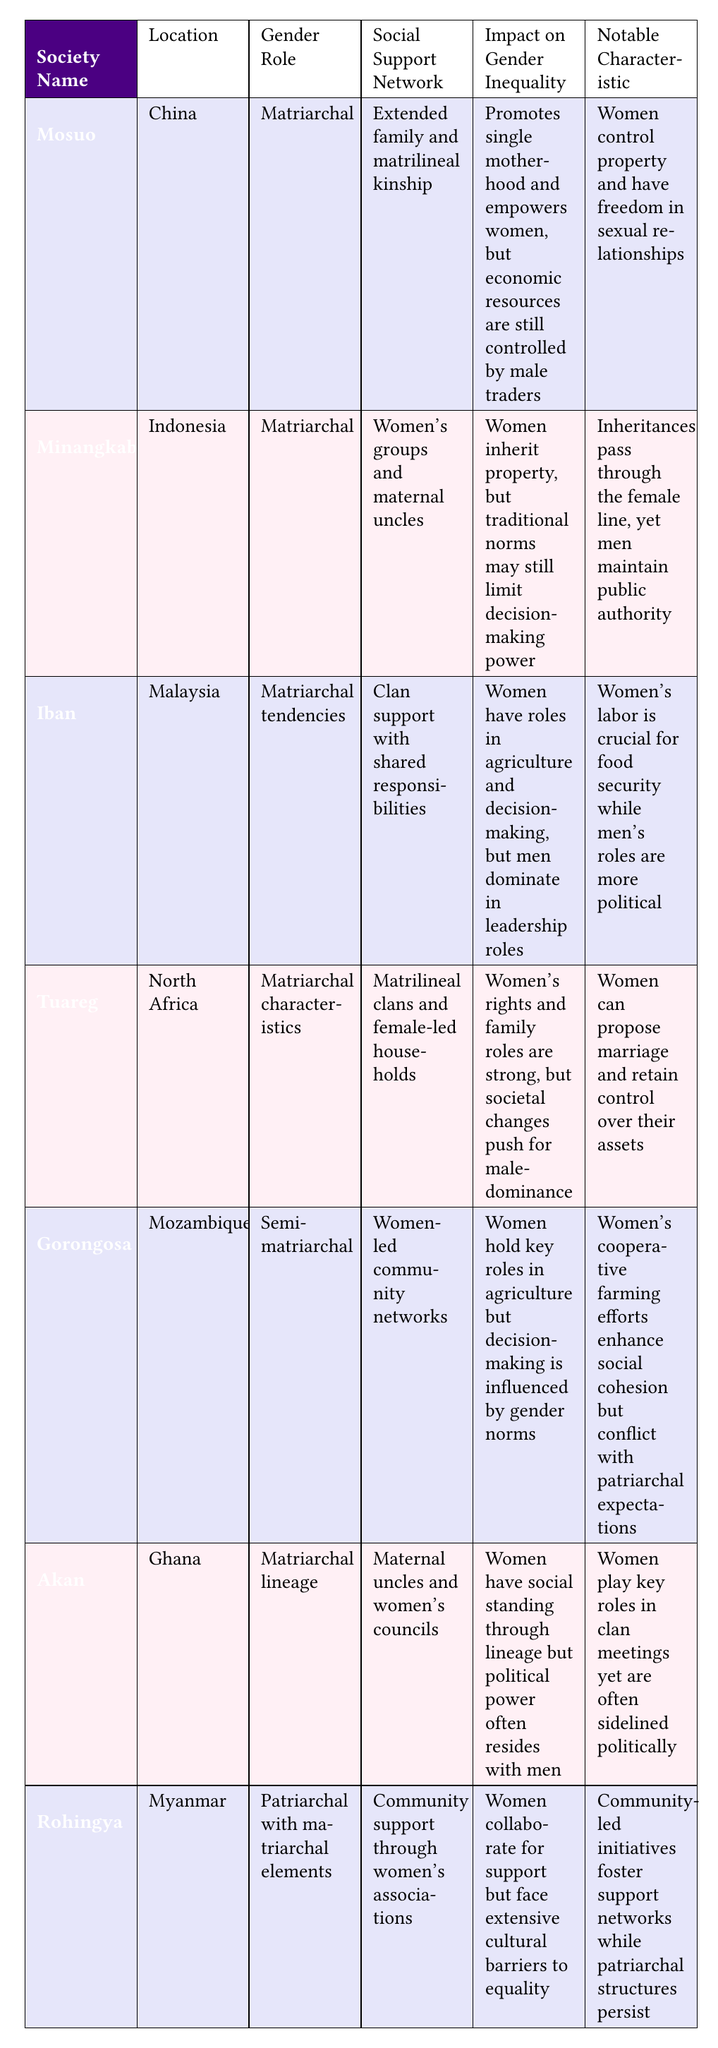What matriarchal society allows women to propose marriage? The table indicates that in the Tuareg society of North Africa, women have the ability to propose marriage. This can be directly referenced from the notable characteristic column of their row in the table.
Answer: Tuareg Which society has women's groups and maternal uncles as their social support network? According to the table, the Minangkabau society in Indonesia utilizes women's groups and maternal uncles as their social support network. This information is directly stated in the corresponding column for that society.
Answer: Minangkabau Are women in the Iban society granted leadership roles? The table reveals that while women in the Iban society have critical roles in agriculture and decision-making, men dominate leadership roles. Thus, the answer is no, women are not granted leadership roles.
Answer: No What is the notable characteristic for the Akan society? The table specifies that the notable characteristic of the Akan society in Ghana is that women play key roles in clan meetings but are often sidelined politically. This information is directly available in the notable characteristic column.
Answer: Women play key roles in clan meetings yet are often sidelined politically How many societies listed are identified as fully matriarchal? The table presents several societies, and upon checking, it shows that 4 societies (Mosuo, Minangkabau, Iban, and Akan) are categorized under gender role as matriarchal. The total count is determined simply by counting the entries under that specific category in the gender role column.
Answer: 4 In which society do women hold key roles in agriculture but face gender norm influences on decision-making? The Gorongosa society in Mozambique is noted for having women who hold significant roles in agriculture while also facing influences from gender norms that affect decision-making. This is indicated in the impact on gender inequality column for that society.
Answer: Gorongosa Which two societies mentioned have a social support network of women's associations? Both the Rohingya in Myanmar and the Gorongosa in Mozambique utilize women's associations within their social support networks. This information is acquired by looking for matching entries in the social support network column.
Answer: Rohingya, Gorongosa What is the impact on gender inequality in the Tuareg society? The table states that in the Tuareg society, women exhibit strong family roles and rights, but societal changes drive a trend toward male dominance. This combines factors from both the impact on gender inequality and notable characteristic columns for a broader understanding.
Answer: Women's rights and family roles are strong, but societal changes push for male-dominance 